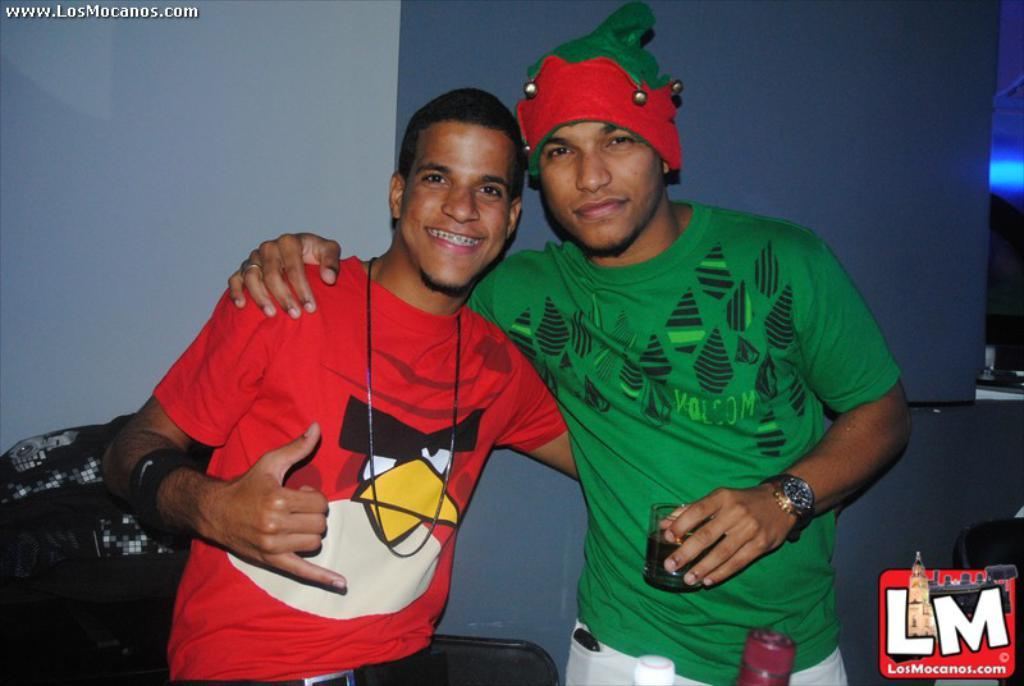How many people are in the image? There are two men standing in the image. What is one of the men holding? One man is holding a glass. What can be seen behind the men? There is an object and a wall behind the men. Can you describe any additional features of the image? The image has watermarks. What type of stitch is being used to sew the icicle in the image? There is no stitch or icicle present in the image. How does the jelly interact with the men in the image? There is no jelly present in the image, so it cannot interact with the men. 